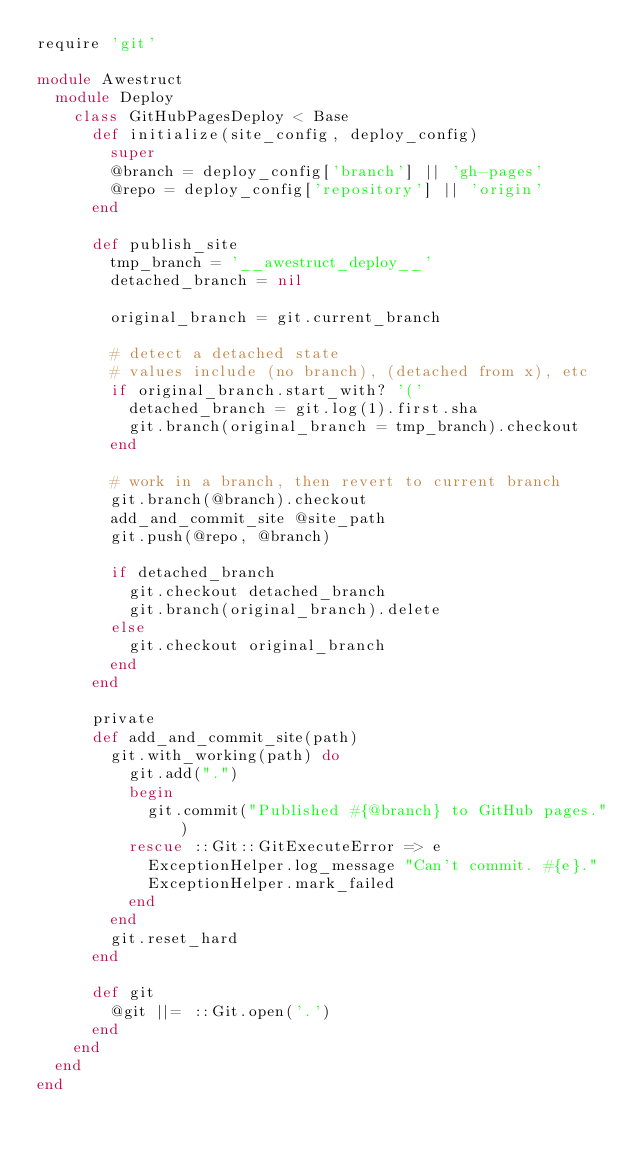Convert code to text. <code><loc_0><loc_0><loc_500><loc_500><_Ruby_>require 'git'

module Awestruct
  module Deploy
    class GitHubPagesDeploy < Base
      def initialize(site_config, deploy_config)
        super
        @branch = deploy_config['branch'] || 'gh-pages'
        @repo = deploy_config['repository'] || 'origin'
      end

      def publish_site
        tmp_branch = '__awestruct_deploy__'
        detached_branch = nil

        original_branch = git.current_branch

        # detect a detached state
        # values include (no branch), (detached from x), etc
        if original_branch.start_with? '('
          detached_branch = git.log(1).first.sha
          git.branch(original_branch = tmp_branch).checkout
        end

        # work in a branch, then revert to current branch
        git.branch(@branch).checkout
        add_and_commit_site @site_path
        git.push(@repo, @branch)

        if detached_branch
          git.checkout detached_branch
          git.branch(original_branch).delete
        else
          git.checkout original_branch
        end
      end

      private
      def add_and_commit_site(path)
        git.with_working(path) do
          git.add(".")
          begin
            git.commit("Published #{@branch} to GitHub pages.")
          rescue ::Git::GitExecuteError => e
            ExceptionHelper.log_message "Can't commit. #{e}."
            ExceptionHelper.mark_failed
          end
        end
        git.reset_hard
      end

      def git
        @git ||= ::Git.open('.')
      end
    end
  end
end
</code> 